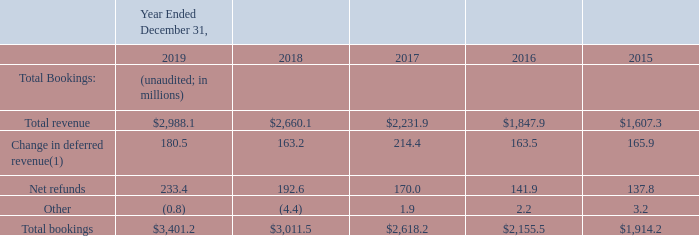Reconciliation of Bookings
The following table reconciles total bookings to total revenue, its most directly comparable GAAP financial measure:
(1) Change in deferred revenue also includes the impact of realized gains or losses from the hedging of bookings in foreign currencies.
What financial items does reconciliation of total bookings consist of? Total revenue, change in deferred revenue, net refunds, other. What is the total bookings for each financial year shown in the table, in chronological order?
Answer scale should be: million. $1,914.2, $2,155.5, $2,618.2, $3,011.5, $3,401.2. What is the net refunds for each financial year shown in the table, in chronological order?
Answer scale should be: million. 137.8, 141.9, 170.0, 192.6, 233.4. Which financial year listed has the highest total bookings? 3,401.2>3,011.5 , 3,401.2>2,618.2 , 3,401.2>2,155.5 , 3,401.2>1,914.2
Answer: 2019. How many financial years had total bookings below $3,000 millions? 2017 ## 2016 ## 2015
Answer: 3. What is the average total revenue for 2018 and 2019?
Answer scale should be: million. (2,988.1+2,660.1)/2
Answer: 2824.1. 